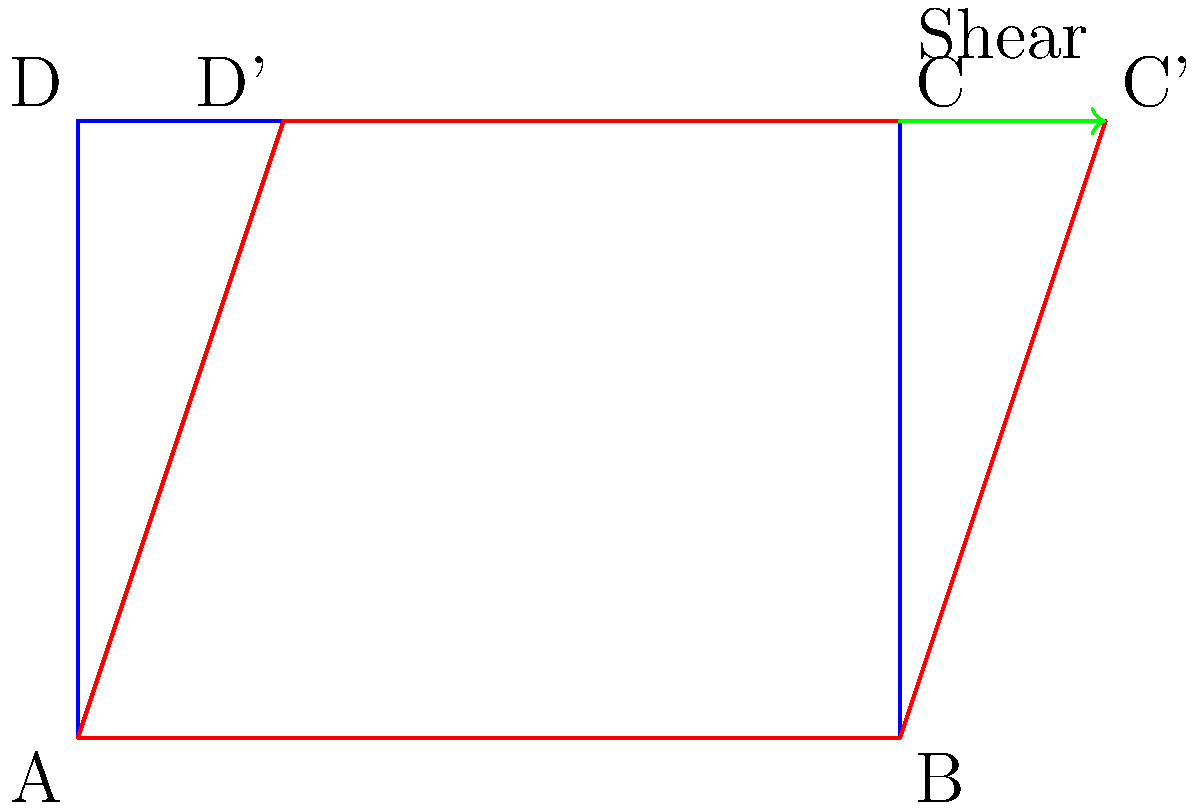In a speculative science fiction scenario, a rectangular time portal is distorted using a shear transformation, resulting in a parallelogram-shaped portal. Given that the original portal has dimensions of 4 units wide and 3 units tall, and the top edge of the portal is shifted 1 unit to the right, what is the shear factor $k$ applied to transform the rectangle into a parallelogram? To solve this problem, we'll follow these steps:

1) In a shear transformation along the x-axis, the new x-coordinate is given by:
   $x' = x + ky$
   where $k$ is the shear factor.

2) The y-coordinate remains unchanged:
   $y' = y$

3) We know that the top edge of the portal is shifted 1 unit to the right. This means:
   - The point (4,3) moves to (5,3)
   - The point (0,3) moves to (1,3)

4) Let's focus on the point (4,3) moving to (5,3):
   $5 = 4 + k(3)$

5) Solve for $k$:
   $5 - 4 = k(3)$
   $1 = k(3)$
   $k = \frac{1}{3}$

6) We can verify this with the other point (0,3) moving to (1,3):
   $1 = 0 + \frac{1}{3}(3)$
   $1 = 1$ (which confirms our result)

Therefore, the shear factor $k$ is $\frac{1}{3}$.
Answer: $\frac{1}{3}$ 